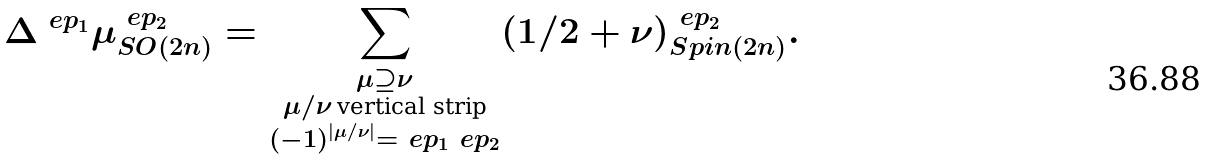Convert formula to latex. <formula><loc_0><loc_0><loc_500><loc_500>\Delta ^ { \ e p _ { 1 } } \mu ^ { \ e p _ { 2 } } _ { S O ( 2 n ) } = \sum _ { \substack { \mu \supseteq \nu \\ \mu / \nu \, \text {vertical strip} \\ ( - 1 ) ^ { | \mu / \nu | } = \ e p _ { 1 } \ e p _ { 2 } } } ( 1 / 2 + \nu ) ^ { \ e p _ { 2 } } _ { S p i n ( 2 n ) } .</formula> 